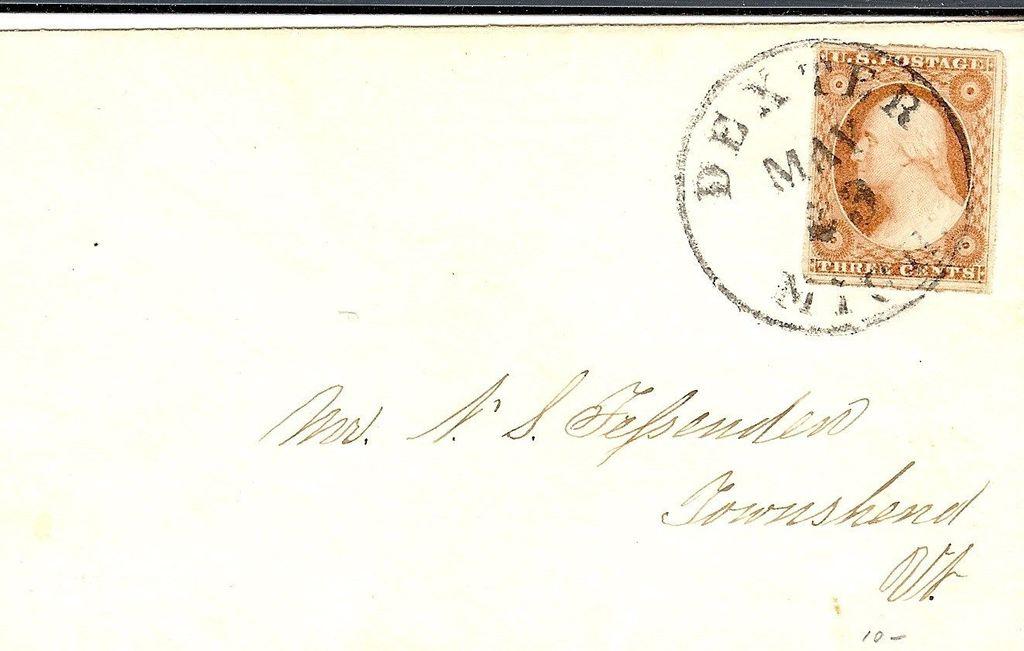What month was this sent?
Provide a short and direct response. May. 